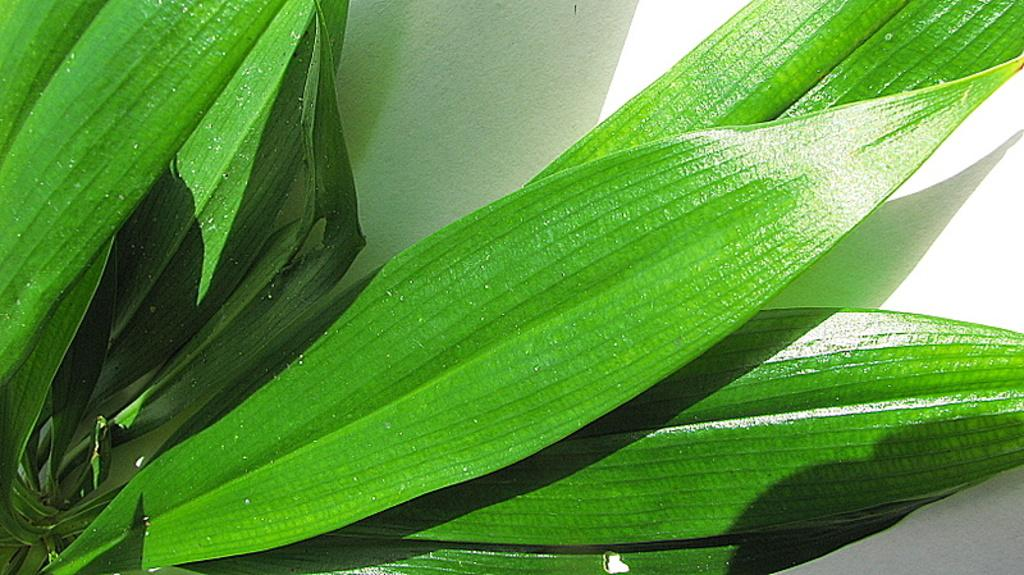What is present in the image? There is a plant in the image. What can be said about the color of the plant? The plant is green in color. What is visible in the background of the image? There is a white colored surface in the background of the image. What is the opinion of the plant about the tank in the image? There is no tank present in the image, and plants do not have opinions. 